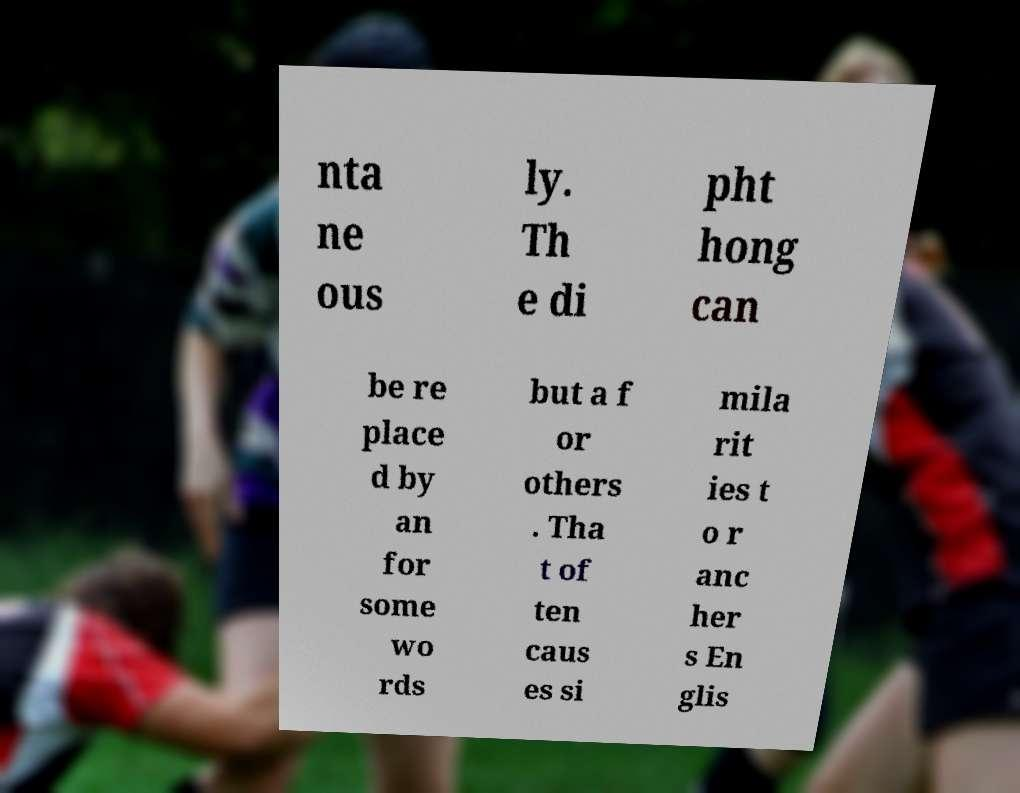What messages or text are displayed in this image? I need them in a readable, typed format. nta ne ous ly. Th e di pht hong can be re place d by an for some wo rds but a f or others . Tha t of ten caus es si mila rit ies t o r anc her s En glis 